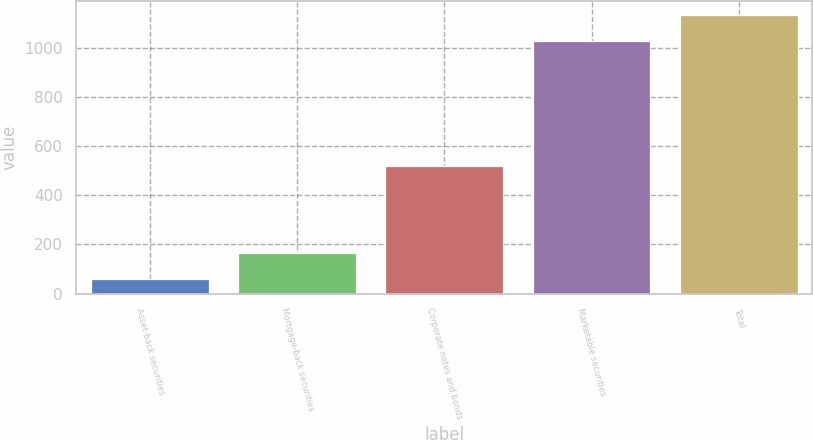<chart> <loc_0><loc_0><loc_500><loc_500><bar_chart><fcel>Asset-back securities<fcel>Mortgage-back securities<fcel>Corporate notes and bonds<fcel>Marketable securities<fcel>Total<nl><fcel>58.2<fcel>165.55<fcel>518<fcel>1029.5<fcel>1136.85<nl></chart> 